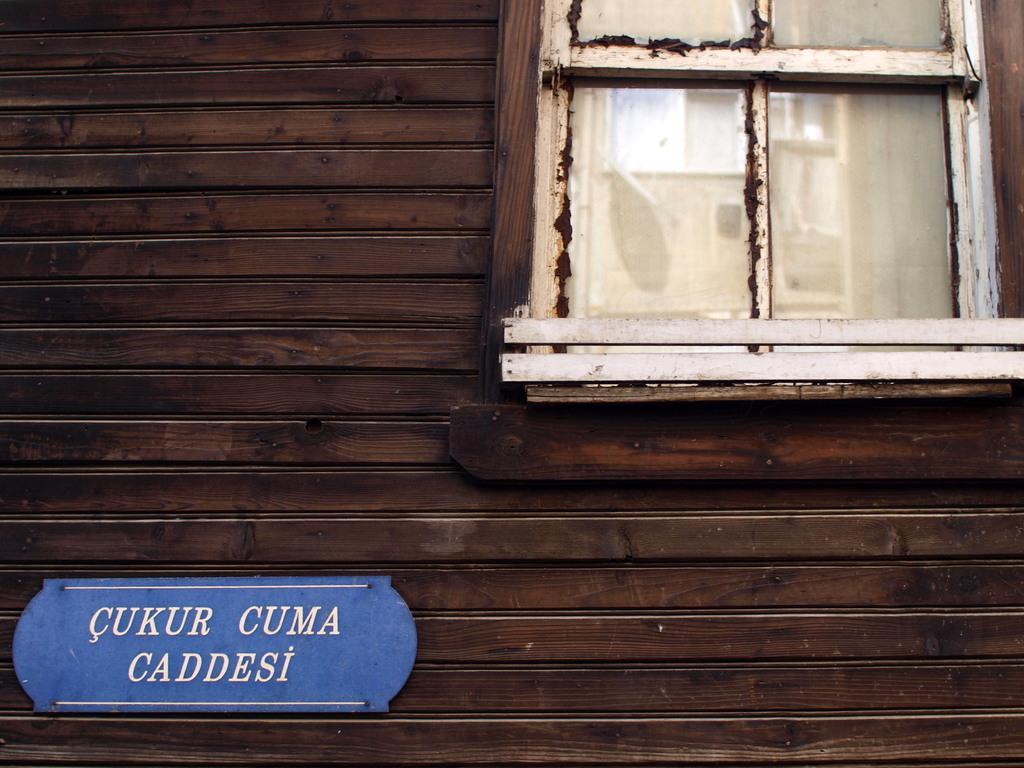Describe this image in one or two sentences. In the image there is a wall with a glass window. And also there is a board with text on it. 